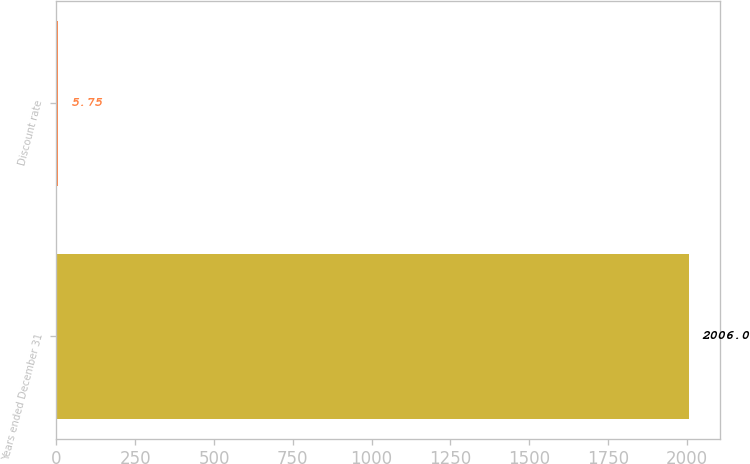Convert chart. <chart><loc_0><loc_0><loc_500><loc_500><bar_chart><fcel>Years ended December 31<fcel>Discount rate<nl><fcel>2006<fcel>5.75<nl></chart> 